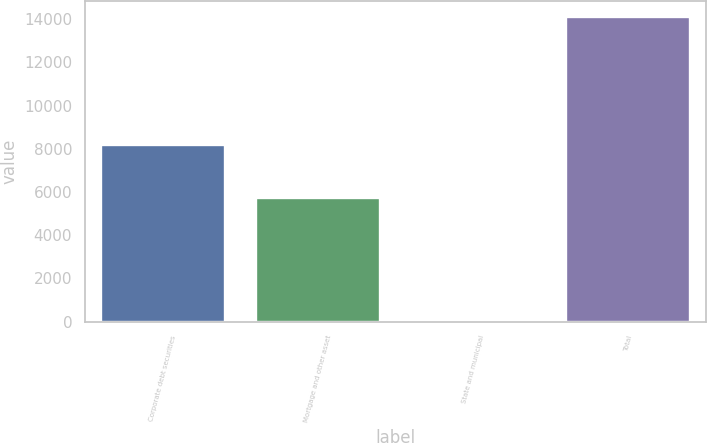<chart> <loc_0><loc_0><loc_500><loc_500><bar_chart><fcel>Corporate debt securities<fcel>Mortgage and other asset<fcel>State and municipal<fcel>Total<nl><fcel>8159<fcel>5715<fcel>73<fcel>14118<nl></chart> 